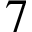Convert formula to latex. <formula><loc_0><loc_0><loc_500><loc_500>7</formula> 